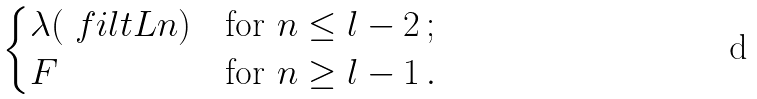<formula> <loc_0><loc_0><loc_500><loc_500>\begin{cases} \lambda ( \ f i l t L n ) & \text {for } n \leq l - 2 \, ; \\ F & \text {for } n \geq l - 1 \, . \end{cases}</formula> 